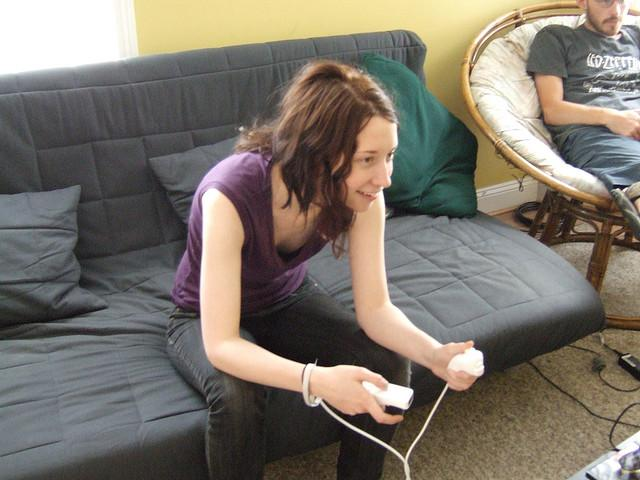What setting are these types of seating often seen in? living room 